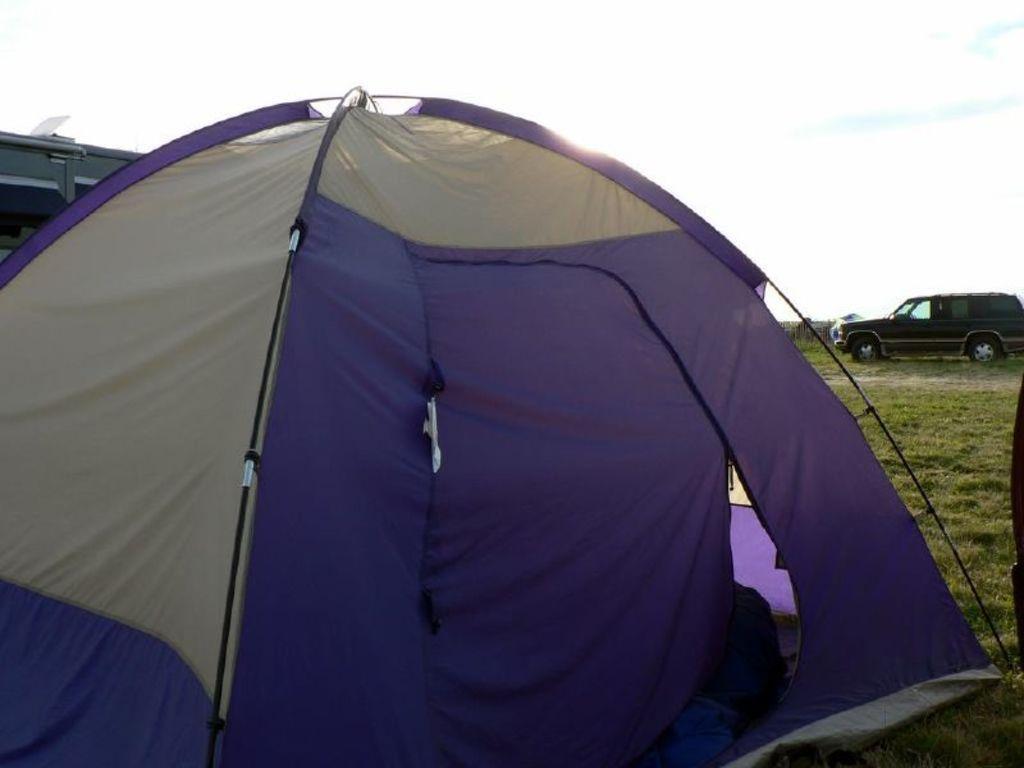How would you summarize this image in a sentence or two? In this picture we can see a tent, in the background we can find a building, a car and grass. 